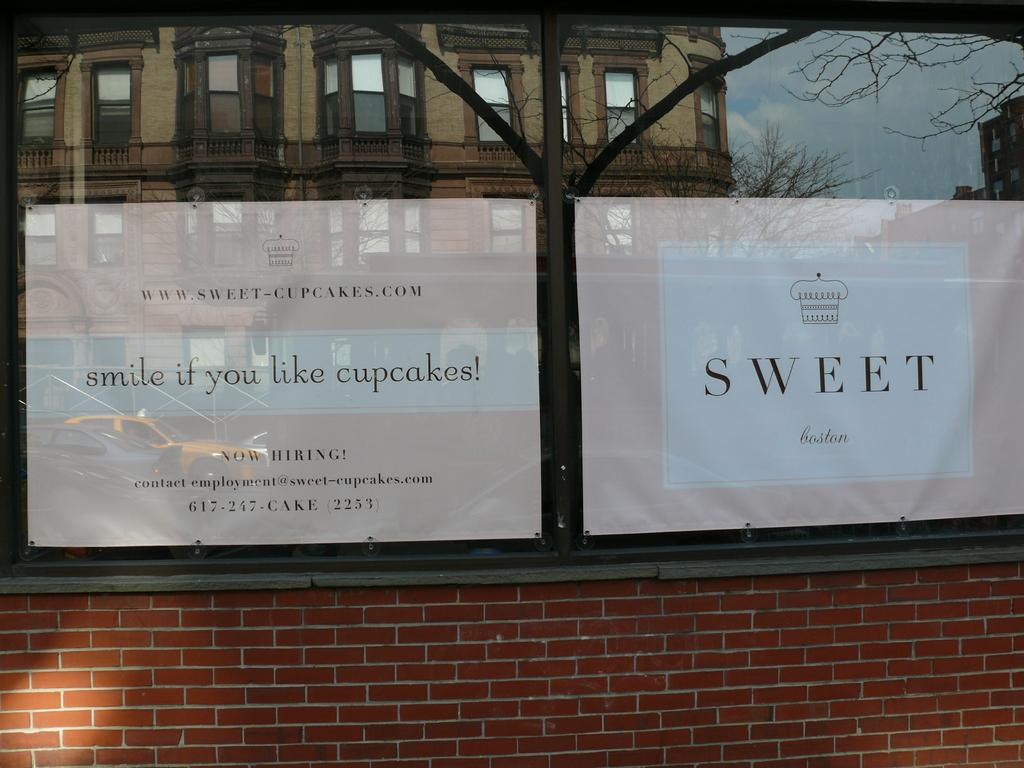What type of openings can be seen in the image? There are windows in the image. What type of information or promotion is displayed in the image? There is an advertisement in the image. What type of structure is present in the image? There is a wall in the image. What type of steel is used to construct the slave in the image? There is no slave or steel present in the image. What type of cable is connected to the advertisement in the image? There is no cable connected to the advertisement in the image. 